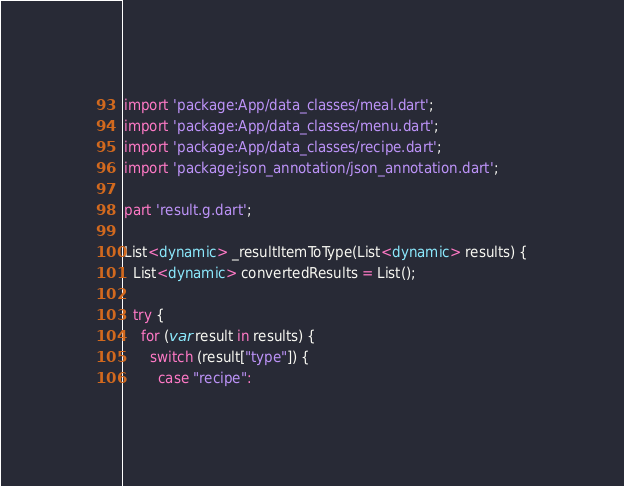Convert code to text. <code><loc_0><loc_0><loc_500><loc_500><_Dart_>import 'package:App/data_classes/meal.dart';
import 'package:App/data_classes/menu.dart';
import 'package:App/data_classes/recipe.dart';
import 'package:json_annotation/json_annotation.dart';

part 'result.g.dart';

List<dynamic> _resultItemToType(List<dynamic> results) {
  List<dynamic> convertedResults = List();

  try {
    for (var result in results) {
      switch (result["type"]) {
        case "recipe":</code> 